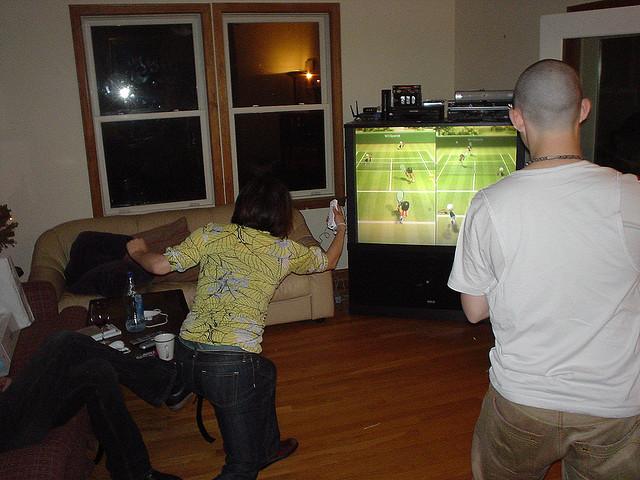Where are the pillows?
Give a very brief answer. Couch. Is it daytime?
Keep it brief. No. What is woman on the left doing?
Keep it brief. Playing wii. 